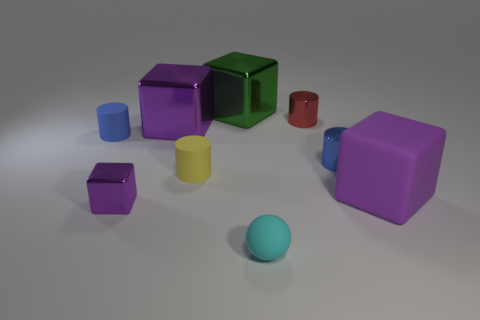Are there any patterns or consistencies in the arrangement of objects in this image? Upon closer observation, the objects in the image don't seem to follow a specific pattern concerning their arrangement; however, they are spaced out in a way that each object is distinct without any overlap, giving an organized yet random placement. 